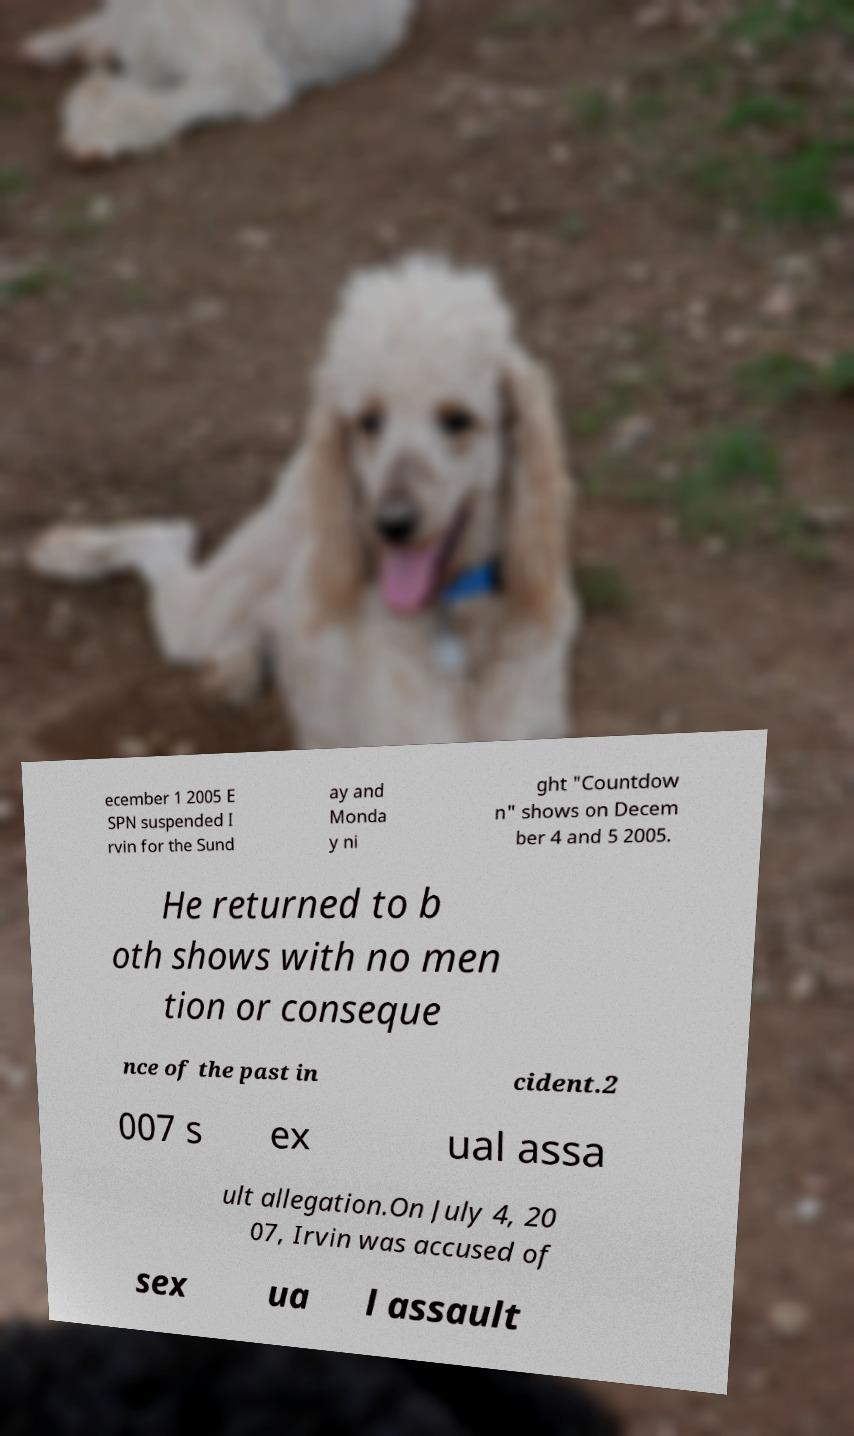Can you read and provide the text displayed in the image?This photo seems to have some interesting text. Can you extract and type it out for me? ecember 1 2005 E SPN suspended I rvin for the Sund ay and Monda y ni ght "Countdow n" shows on Decem ber 4 and 5 2005. He returned to b oth shows with no men tion or conseque nce of the past in cident.2 007 s ex ual assa ult allegation.On July 4, 20 07, Irvin was accused of sex ua l assault 